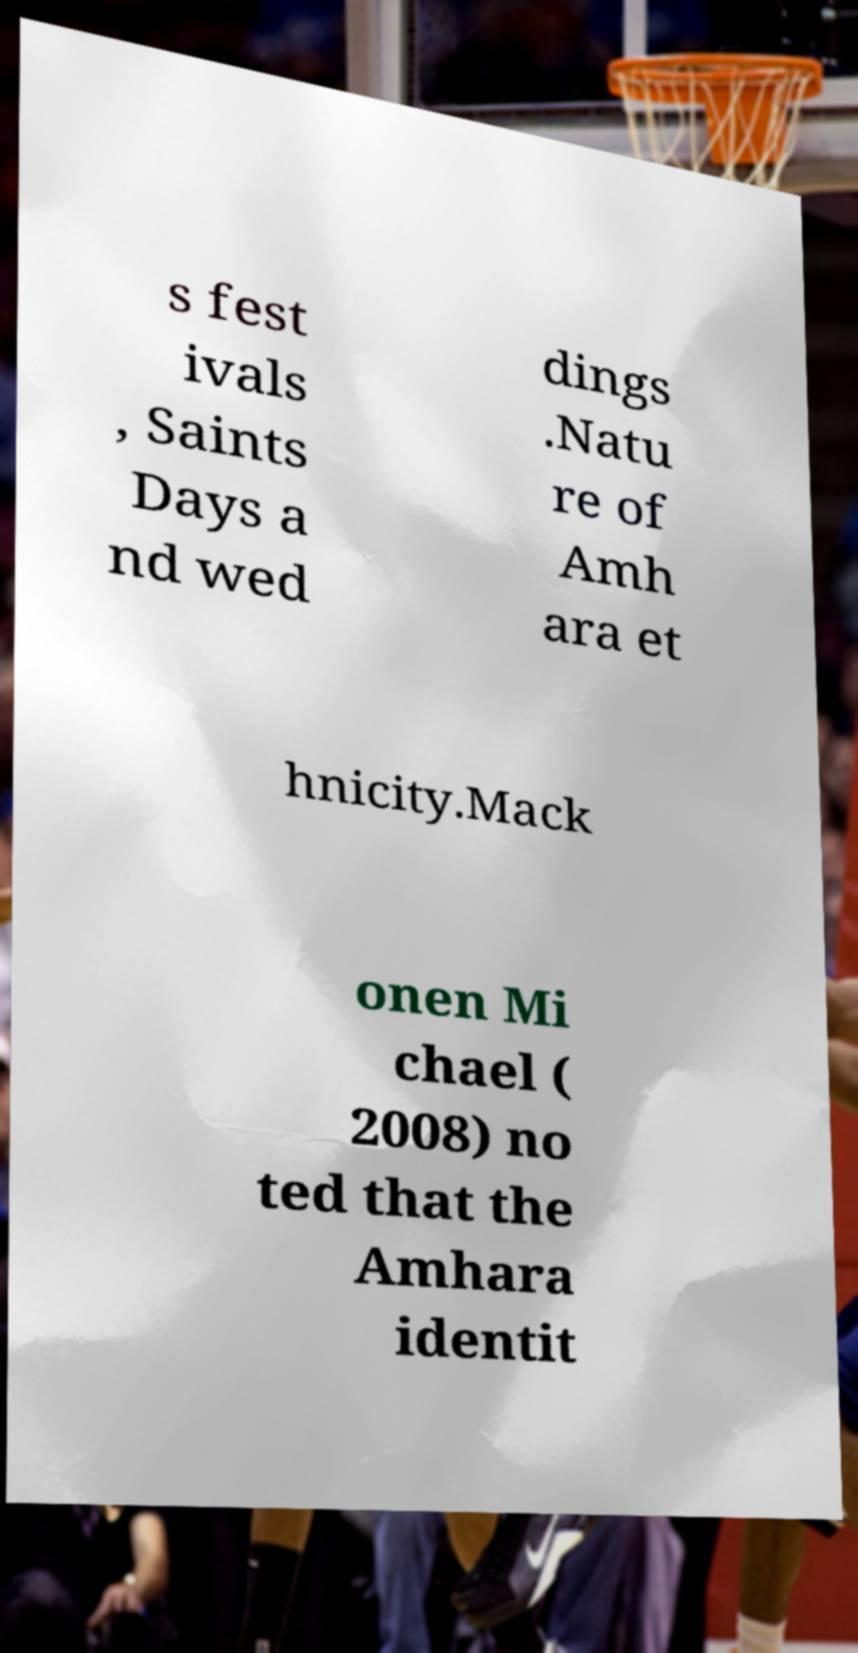Please identify and transcribe the text found in this image. s fest ivals , Saints Days a nd wed dings .Natu re of Amh ara et hnicity.Mack onen Mi chael ( 2008) no ted that the Amhara identit 